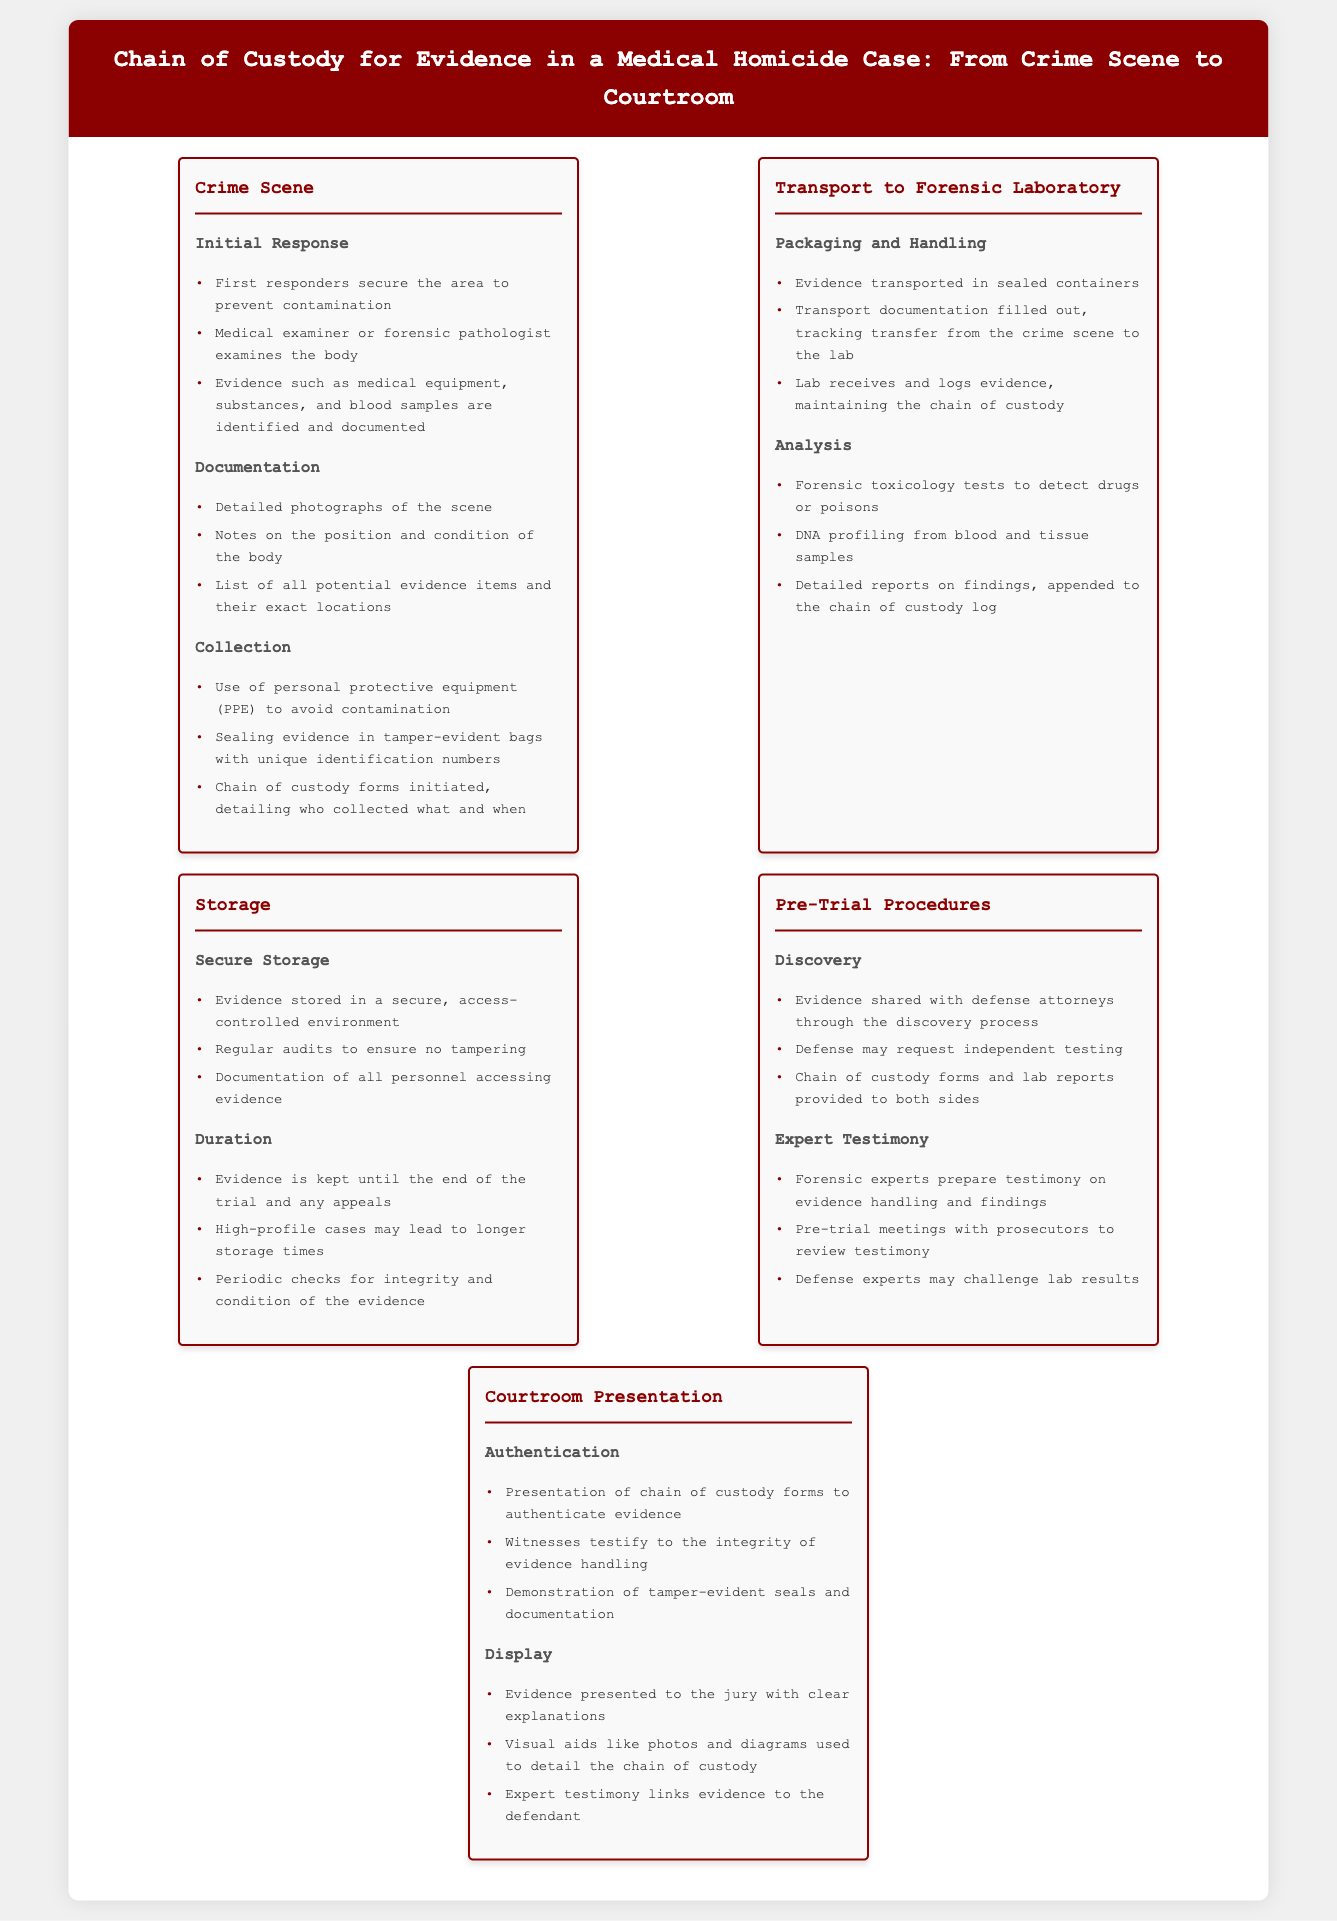What is the first step taken by first responders? The first step taken by first responders is to secure the area to prevent contamination.
Answer: Secure the area What is the role of the medical examiner in the crime scene? The medical examiner or forensic pathologist examines the body at the crime scene.
Answer: Examines the body What type of tests are conducted in the forensic laboratory? Forensic toxicology tests to detect drugs or poisons are conducted in the laboratory.
Answer: Toxicology tests What ensures the integrity of evidence during storage? Regular audits ensure no tampering with the stored evidence.
Answer: Regular audits During the discovery process, what is shared with defense attorneys? Evidence is shared with defense attorneys through the discovery process.
Answer: Evidence What is presented in the courtroom to authenticate evidence? Chain of custody forms are presented to authenticate the evidence in court.
Answer: Chain of custody forms How are evidence items sealed during collection? Evidence items are sealed in tamper-evident bags with unique identification numbers.
Answer: Tamper-evident bags What are forensic experts tasked with in pre-trial procedures? Forensic experts prepare testimony on evidence handling and findings.
Answer: Prepare testimony What documentation is filled out when transporting evidence? Transport documentation is filled out, tracking transfer from the crime scene to the lab.
Answer: Transport documentation 